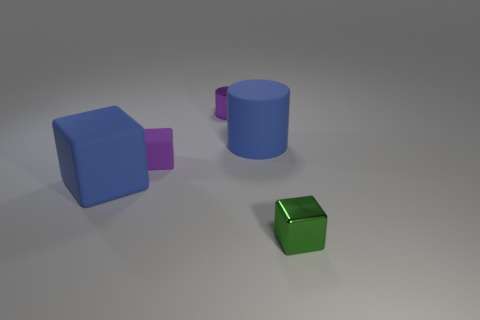There is a purple cylinder; is its size the same as the blue rubber object behind the blue rubber block?
Give a very brief answer. No. What is the size of the other object that is the same shape as the tiny purple metallic object?
Keep it short and to the point. Large. There is a metal object in front of the purple metal object; is it the same size as the purple shiny object that is behind the small rubber object?
Make the answer very short. Yes. How many large objects are metal objects or purple shiny cylinders?
Provide a succinct answer. 0. What number of things are in front of the large cylinder and on the right side of the purple cube?
Provide a succinct answer. 1. Do the blue block and the purple thing in front of the metallic cylinder have the same material?
Your answer should be compact. Yes. What number of cyan objects are cylinders or big rubber cylinders?
Your answer should be compact. 0. Are there any cylinders that have the same size as the purple metallic object?
Offer a very short reply. No. There is a cube on the left side of the tiny purple object in front of the big blue matte thing on the right side of the tiny purple metal thing; what is its material?
Give a very brief answer. Rubber. Are there the same number of blue matte blocks that are in front of the blue rubber cube and small rubber blocks?
Offer a very short reply. No. 